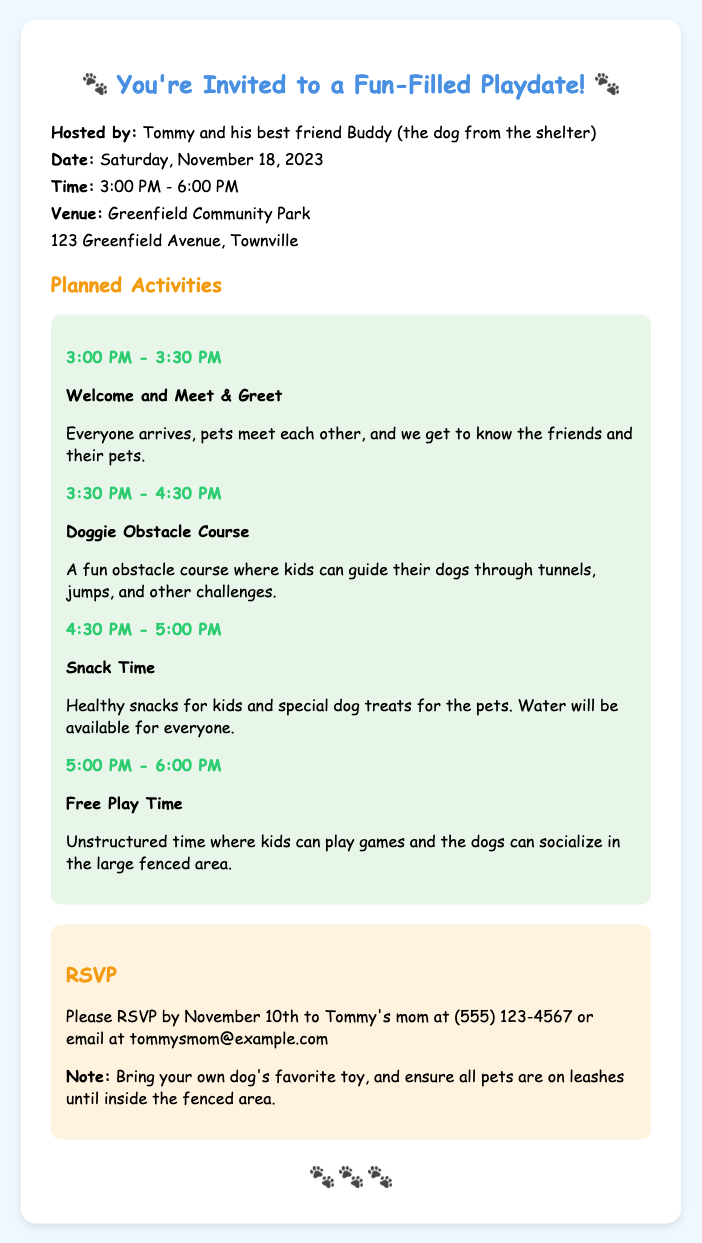What is the name of the host? The host is mentioned in the document as Tommy and his best friend Buddy.
Answer: Tommy and Buddy What is the date of the playdate? The document specifies the date of the playdate as Saturday, November 18, 2023.
Answer: November 18, 2023 Where is the playdate taking place? The venue for the playdate is listed in the document as Greenfield Community Park.
Answer: Greenfield Community Park What time does the Doggie Obstacle Course start? The schedule shows that the Doggie Obstacle Course starts at 3:30 PM.
Answer: 3:30 PM What is one of the planned activities for the playdate? The document lists several planned activities, one being the Snack Time for kids and pets.
Answer: Snack Time How long is the Free Play Time scheduled for? The document states that Free Play Time is scheduled from 5:00 PM to 6:00 PM, which is one hour.
Answer: One hour What should guests bring for their dogs? The RSVP card requests guests to bring their own dog's favorite toy.
Answer: Dog's favorite toy By when should you RSVP? The document specifies that RSVPs should be made by November 10th.
Answer: November 10th What must all pets be on until entering the fenced area? The document indicates that all pets should be on leashes until they are in the fenced area.
Answer: Leashes 